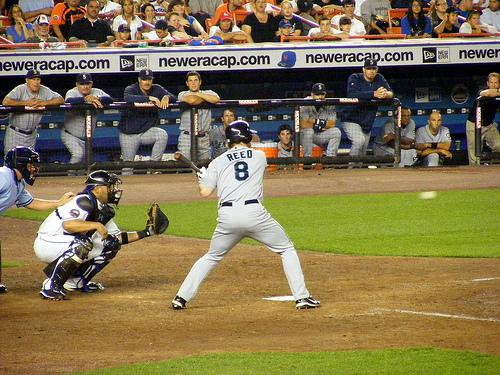Question: what website is being advertised in the background?
Choices:
A. GE appliances.
B. Rooms to go.
C. Neweracap.com.
D. Walmart.
Answer with the letter. Answer: C Question: what direction is the ball approaching from?
Choices:
A. Left.
B. Right.
C. East.
D. West.
Answer with the letter. Answer: B Question: what direction is the batter facing?
Choices:
A. Right.
B. Towards ball.
C. Towards bowler.
D. Left.
Answer with the letter. Answer: A Question: where was the picture taken?
Choices:
A. On a gold course.
B. In a skating rink.
C. In a baseball stadium.
D. On a tennis court.
Answer with the letter. Answer: C Question: what name is on the batter's shirt?
Choices:
A. Smith.
B. Jones.
C. Reed.
D. Martinez.
Answer with the letter. Answer: C 